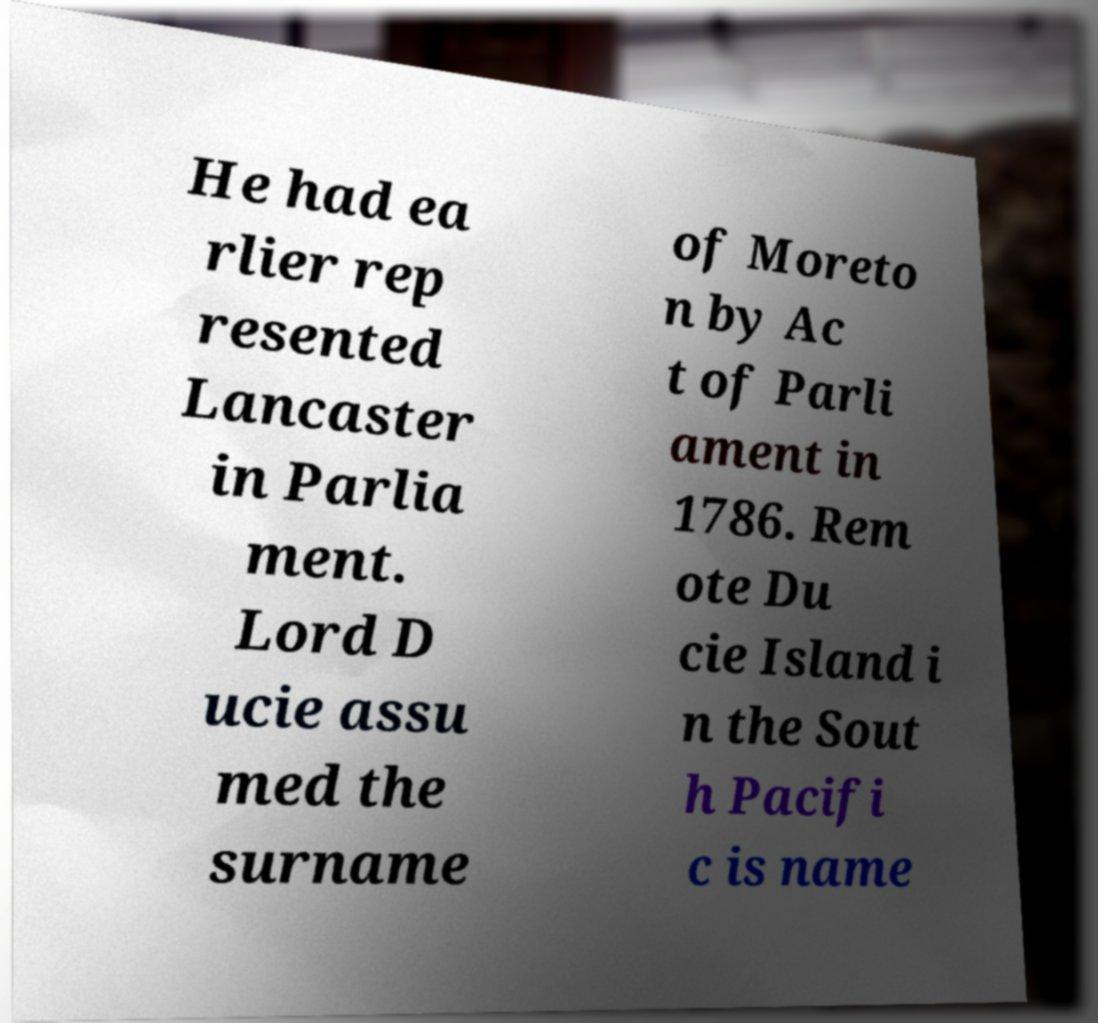Can you read and provide the text displayed in the image?This photo seems to have some interesting text. Can you extract and type it out for me? He had ea rlier rep resented Lancaster in Parlia ment. Lord D ucie assu med the surname of Moreto n by Ac t of Parli ament in 1786. Rem ote Du cie Island i n the Sout h Pacifi c is name 